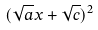Convert formula to latex. <formula><loc_0><loc_0><loc_500><loc_500>( \sqrt { a } x + \sqrt { c } ) ^ { 2 }</formula> 